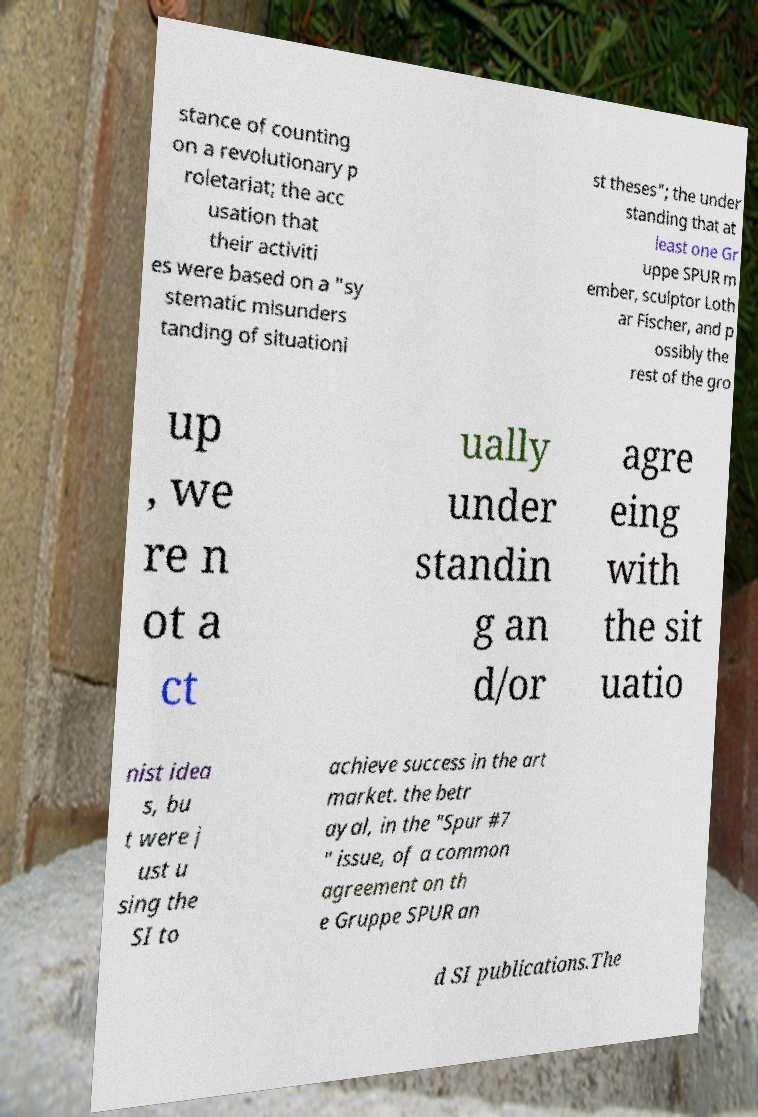There's text embedded in this image that I need extracted. Can you transcribe it verbatim? stance of counting on a revolutionary p roletariat; the acc usation that their activiti es were based on a "sy stematic misunders tanding of situationi st theses"; the under standing that at least one Gr uppe SPUR m ember, sculptor Loth ar Fischer, and p ossibly the rest of the gro up , we re n ot a ct ually under standin g an d/or agre eing with the sit uatio nist idea s, bu t were j ust u sing the SI to achieve success in the art market. the betr ayal, in the "Spur #7 " issue, of a common agreement on th e Gruppe SPUR an d SI publications.The 